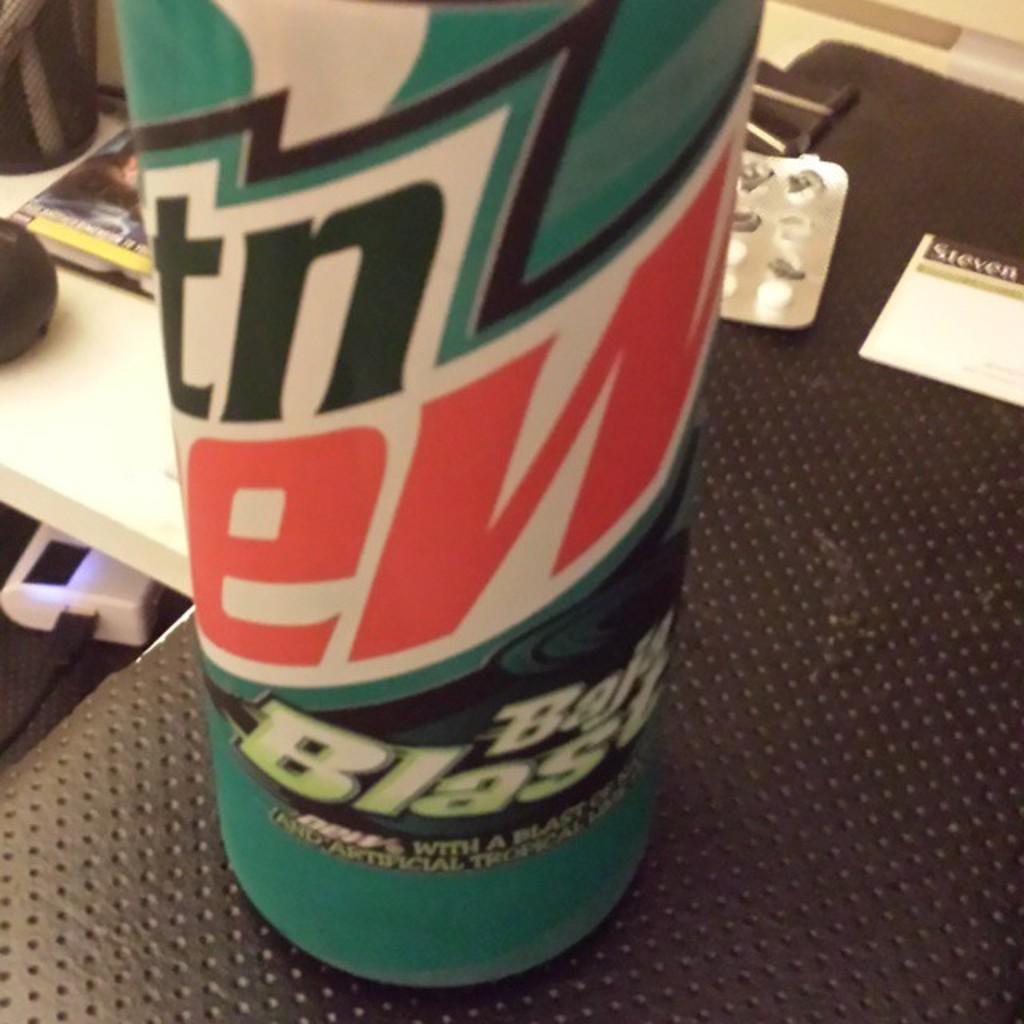What flavor soda is this?
Ensure brevity in your answer.  Baja blast. What brand of soda is this?
Make the answer very short. Mountain dew. 